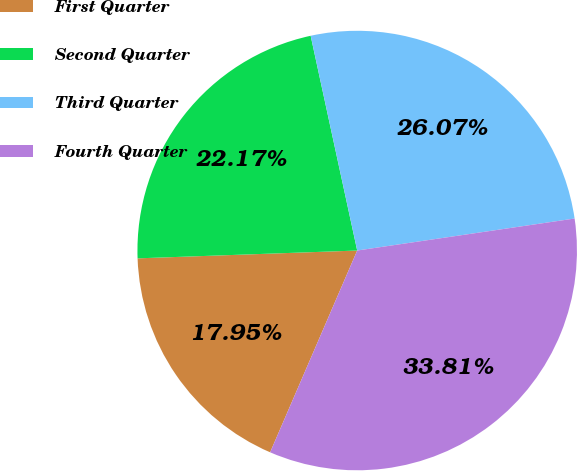Convert chart to OTSL. <chart><loc_0><loc_0><loc_500><loc_500><pie_chart><fcel>First Quarter<fcel>Second Quarter<fcel>Third Quarter<fcel>Fourth Quarter<nl><fcel>17.95%<fcel>22.17%<fcel>26.07%<fcel>33.81%<nl></chart> 